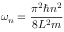<formula> <loc_0><loc_0><loc_500><loc_500>\omega _ { n } = { \frac { \pi ^ { 2 } \hbar { n } ^ { 2 } } { 8 L ^ { 2 } m } }</formula> 